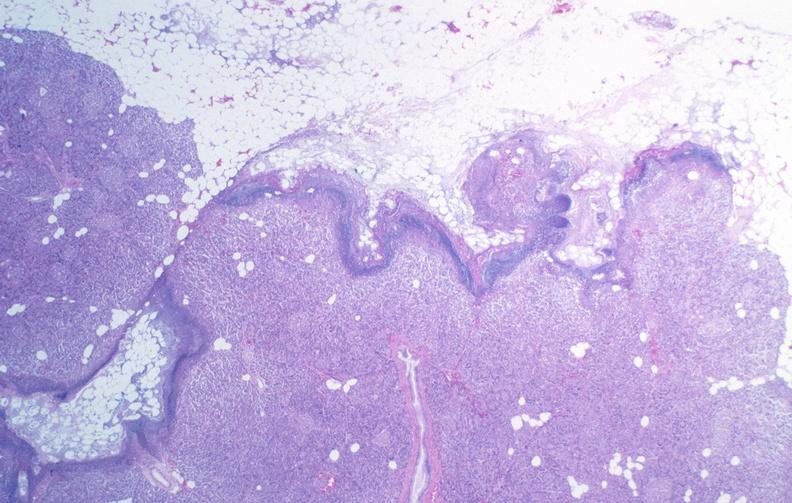what does this image show?
Answer the question using a single word or phrase. Pancreatic fat necrosis 